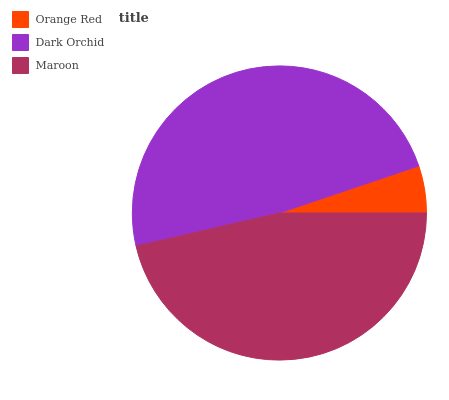Is Orange Red the minimum?
Answer yes or no. Yes. Is Dark Orchid the maximum?
Answer yes or no. Yes. Is Maroon the minimum?
Answer yes or no. No. Is Maroon the maximum?
Answer yes or no. No. Is Dark Orchid greater than Maroon?
Answer yes or no. Yes. Is Maroon less than Dark Orchid?
Answer yes or no. Yes. Is Maroon greater than Dark Orchid?
Answer yes or no. No. Is Dark Orchid less than Maroon?
Answer yes or no. No. Is Maroon the high median?
Answer yes or no. Yes. Is Maroon the low median?
Answer yes or no. Yes. Is Dark Orchid the high median?
Answer yes or no. No. Is Orange Red the low median?
Answer yes or no. No. 